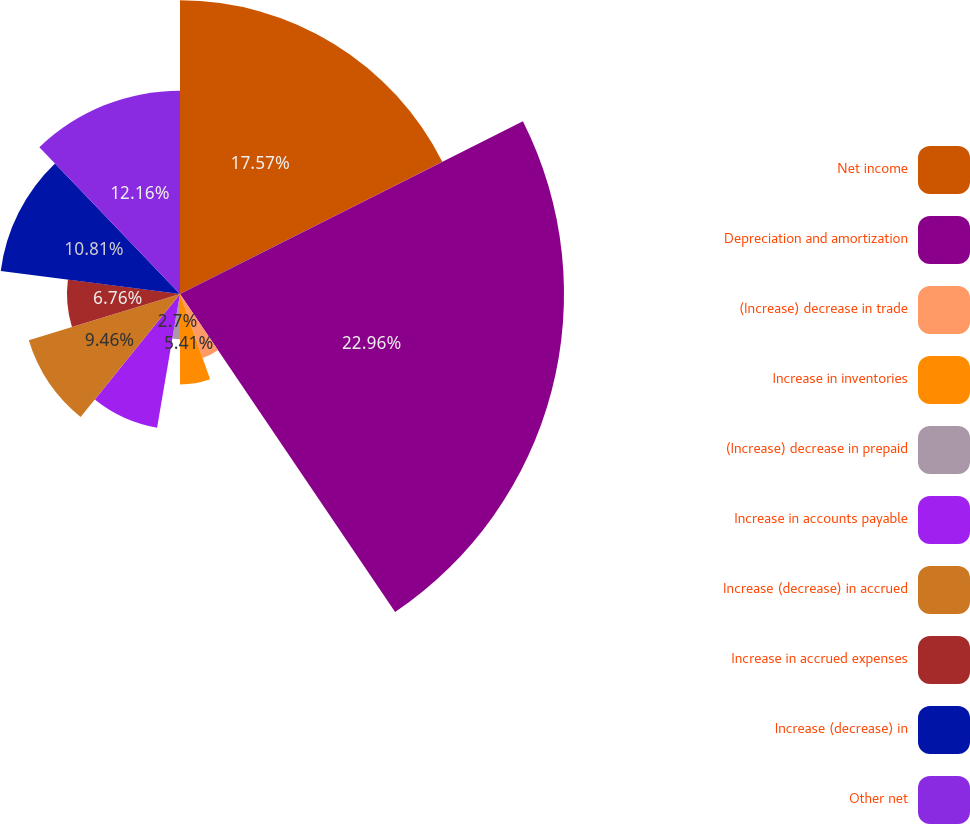Convert chart to OTSL. <chart><loc_0><loc_0><loc_500><loc_500><pie_chart><fcel>Net income<fcel>Depreciation and amortization<fcel>(Increase) decrease in trade<fcel>Increase in inventories<fcel>(Increase) decrease in prepaid<fcel>Increase in accounts payable<fcel>Increase (decrease) in accrued<fcel>Increase in accrued expenses<fcel>Increase (decrease) in<fcel>Other net<nl><fcel>17.57%<fcel>22.97%<fcel>4.06%<fcel>5.41%<fcel>2.7%<fcel>8.11%<fcel>9.46%<fcel>6.76%<fcel>10.81%<fcel>12.16%<nl></chart> 